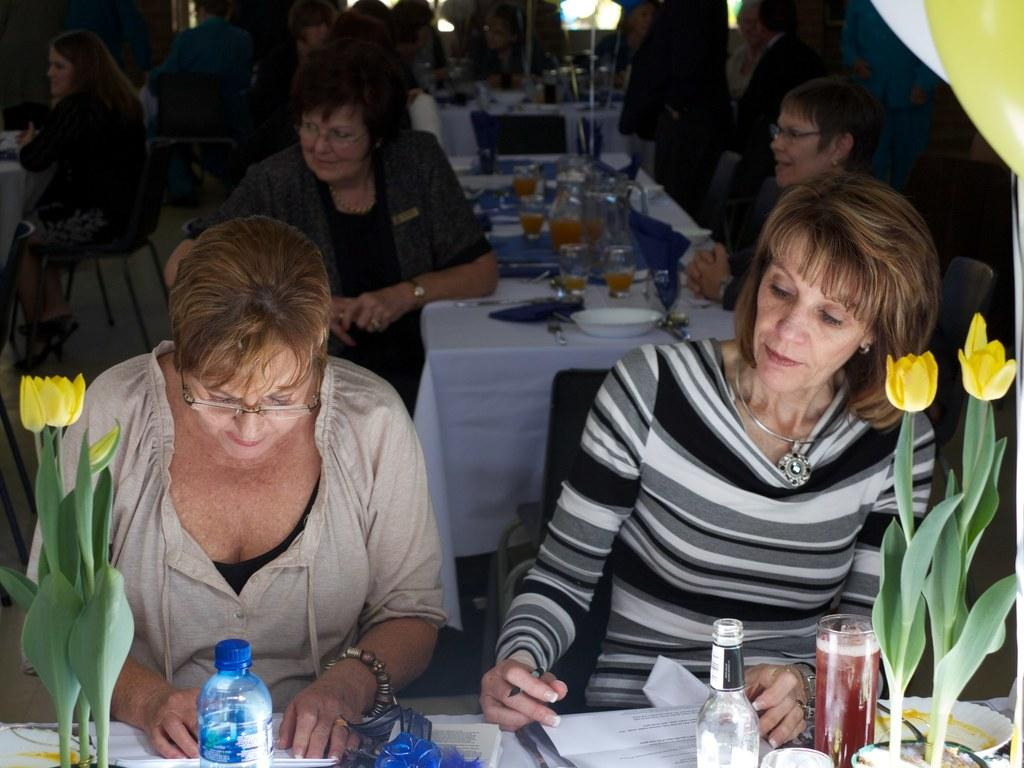What are the people in the image doing? There is a group of people sitting on chairs in the image. What can be seen on the table in the image? There is a water bottle, a flower pot, a paper, a plate, a spoon, and a glass on the table in the image. What type of calendar is hanging on the wall in the image? There is no calendar present in the image. What kind of lamp is providing light in the image? There is no lamp present in the image. 